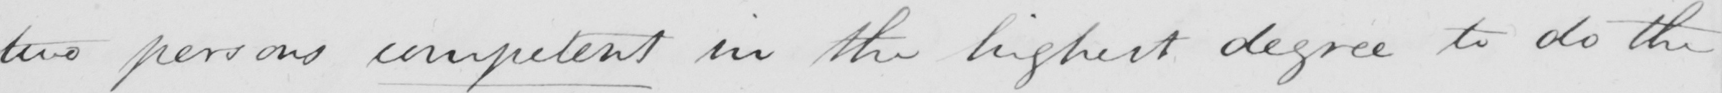What is written in this line of handwriting? two persons competent in the highest degree to do the 